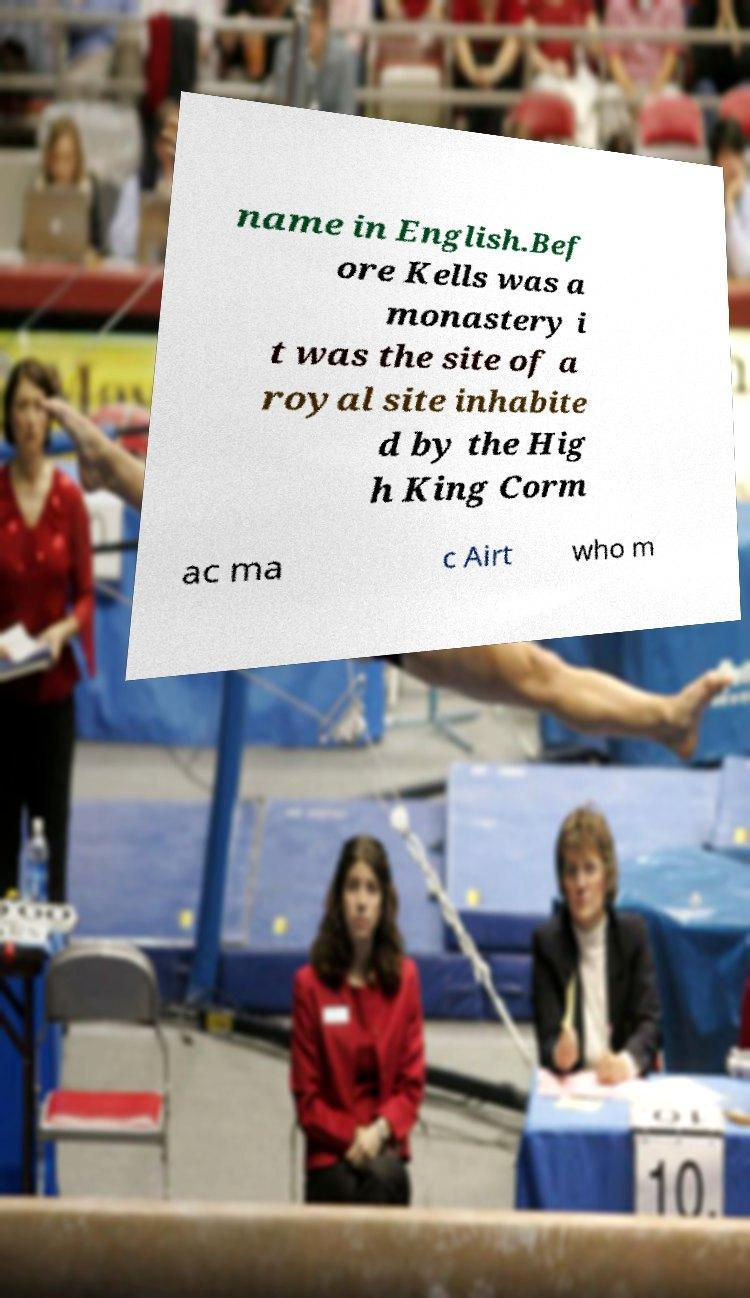Can you accurately transcribe the text from the provided image for me? name in English.Bef ore Kells was a monastery i t was the site of a royal site inhabite d by the Hig h King Corm ac ma c Airt who m 